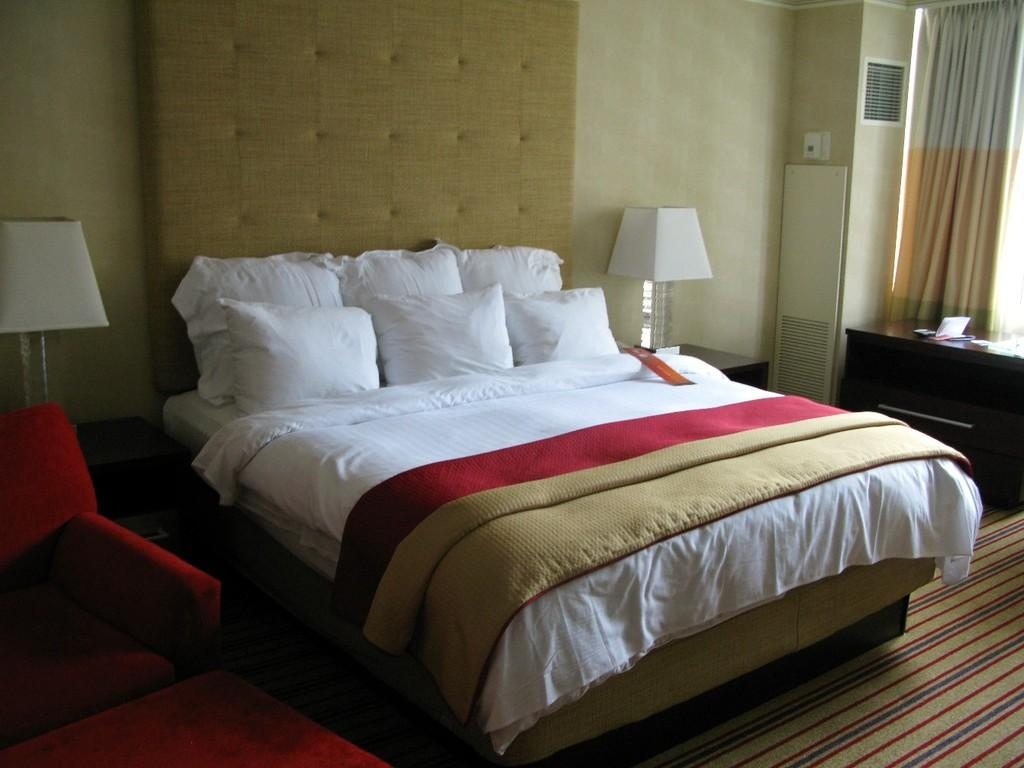What type of objects are labeled in the image? There are pillows in the image, and they are labeled as "best" and "andrew." What type of lighting fixture is present in the image? There is a lamp in the image. What type of furniture is present in the image? There is a table in the image. What type of sponge is used to clean the pillows in the image? There is no sponge visible in the image, and it is not mentioned that the pillows are being cleaned. How does the "best" pillow compare to the "andrew" pillow in the image? The image does not provide any information about a comparison between the two pillows. 